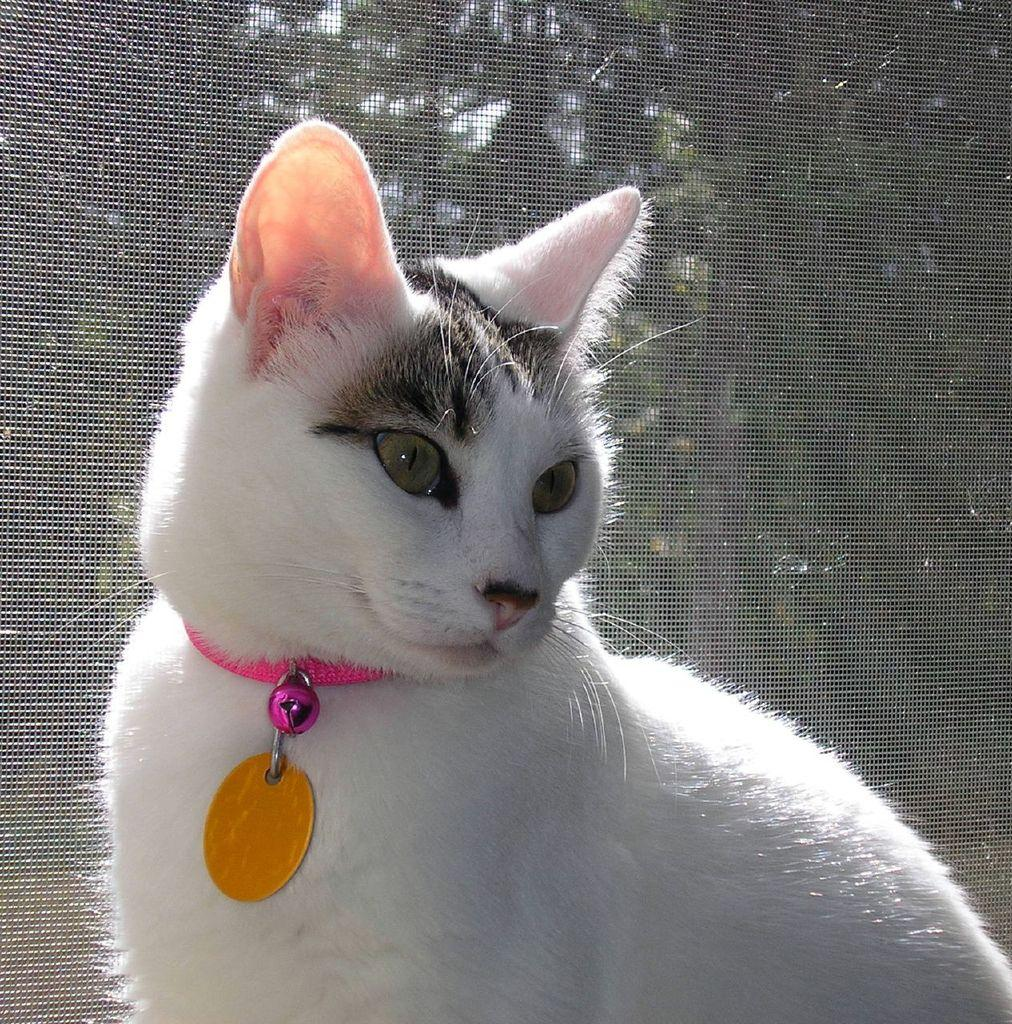What type of animal can be seen in the image? There is a cat in the image. What can be seen in the background of the image? There is a mesh and greenery in the background of the image. How does the cat compare to a tramp in the image? There is no tramp present in the image, so it is not possible to make a comparison. 